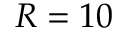Convert formula to latex. <formula><loc_0><loc_0><loc_500><loc_500>R = 1 0</formula> 